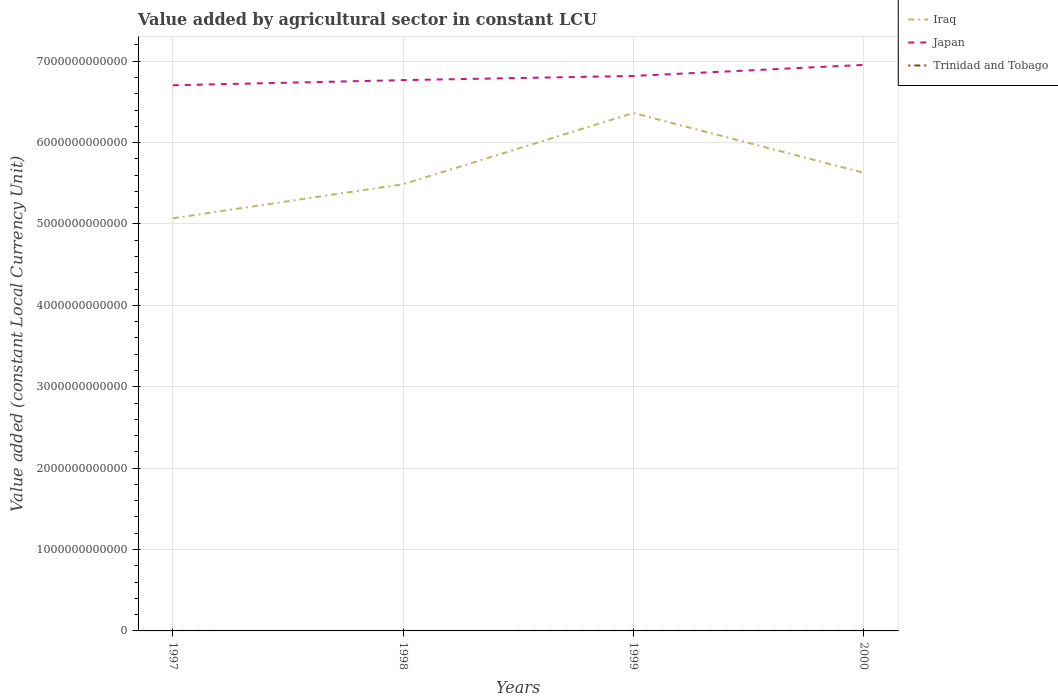Across all years, what is the maximum value added by agricultural sector in Japan?
Offer a very short reply. 6.70e+12. What is the total value added by agricultural sector in Iraq in the graph?
Keep it short and to the point. -1.40e+11. What is the difference between the highest and the second highest value added by agricultural sector in Japan?
Provide a succinct answer. 2.50e+11. How many lines are there?
Ensure brevity in your answer.  3. What is the difference between two consecutive major ticks on the Y-axis?
Keep it short and to the point. 1.00e+12. Does the graph contain any zero values?
Ensure brevity in your answer.  No. What is the title of the graph?
Keep it short and to the point. Value added by agricultural sector in constant LCU. Does "Angola" appear as one of the legend labels in the graph?
Provide a succinct answer. No. What is the label or title of the X-axis?
Your answer should be very brief. Years. What is the label or title of the Y-axis?
Make the answer very short. Value added (constant Local Currency Unit). What is the Value added (constant Local Currency Unit) of Iraq in 1997?
Provide a succinct answer. 5.07e+12. What is the Value added (constant Local Currency Unit) in Japan in 1997?
Offer a very short reply. 6.70e+12. What is the Value added (constant Local Currency Unit) in Trinidad and Tobago in 1997?
Offer a terse response. 6.75e+08. What is the Value added (constant Local Currency Unit) in Iraq in 1998?
Provide a short and direct response. 5.49e+12. What is the Value added (constant Local Currency Unit) of Japan in 1998?
Your answer should be very brief. 6.77e+12. What is the Value added (constant Local Currency Unit) of Trinidad and Tobago in 1998?
Give a very brief answer. 6.12e+08. What is the Value added (constant Local Currency Unit) of Iraq in 1999?
Ensure brevity in your answer.  6.36e+12. What is the Value added (constant Local Currency Unit) in Japan in 1999?
Offer a very short reply. 6.82e+12. What is the Value added (constant Local Currency Unit) in Trinidad and Tobago in 1999?
Give a very brief answer. 7.14e+08. What is the Value added (constant Local Currency Unit) in Iraq in 2000?
Make the answer very short. 5.63e+12. What is the Value added (constant Local Currency Unit) of Japan in 2000?
Give a very brief answer. 6.95e+12. What is the Value added (constant Local Currency Unit) in Trinidad and Tobago in 2000?
Give a very brief answer. 6.97e+08. Across all years, what is the maximum Value added (constant Local Currency Unit) in Iraq?
Make the answer very short. 6.36e+12. Across all years, what is the maximum Value added (constant Local Currency Unit) in Japan?
Your response must be concise. 6.95e+12. Across all years, what is the maximum Value added (constant Local Currency Unit) in Trinidad and Tobago?
Keep it short and to the point. 7.14e+08. Across all years, what is the minimum Value added (constant Local Currency Unit) in Iraq?
Your answer should be very brief. 5.07e+12. Across all years, what is the minimum Value added (constant Local Currency Unit) of Japan?
Provide a succinct answer. 6.70e+12. Across all years, what is the minimum Value added (constant Local Currency Unit) of Trinidad and Tobago?
Make the answer very short. 6.12e+08. What is the total Value added (constant Local Currency Unit) in Iraq in the graph?
Your answer should be very brief. 2.26e+13. What is the total Value added (constant Local Currency Unit) in Japan in the graph?
Keep it short and to the point. 2.72e+13. What is the total Value added (constant Local Currency Unit) in Trinidad and Tobago in the graph?
Offer a very short reply. 2.70e+09. What is the difference between the Value added (constant Local Currency Unit) in Iraq in 1997 and that in 1998?
Offer a terse response. -4.19e+11. What is the difference between the Value added (constant Local Currency Unit) of Japan in 1997 and that in 1998?
Offer a terse response. -6.31e+1. What is the difference between the Value added (constant Local Currency Unit) in Trinidad and Tobago in 1997 and that in 1998?
Your response must be concise. 6.28e+07. What is the difference between the Value added (constant Local Currency Unit) in Iraq in 1997 and that in 1999?
Your response must be concise. -1.29e+12. What is the difference between the Value added (constant Local Currency Unit) in Japan in 1997 and that in 1999?
Your answer should be compact. -1.15e+11. What is the difference between the Value added (constant Local Currency Unit) of Trinidad and Tobago in 1997 and that in 1999?
Provide a short and direct response. -3.92e+07. What is the difference between the Value added (constant Local Currency Unit) of Iraq in 1997 and that in 2000?
Offer a terse response. -5.58e+11. What is the difference between the Value added (constant Local Currency Unit) in Japan in 1997 and that in 2000?
Provide a succinct answer. -2.50e+11. What is the difference between the Value added (constant Local Currency Unit) of Trinidad and Tobago in 1997 and that in 2000?
Your answer should be compact. -2.23e+07. What is the difference between the Value added (constant Local Currency Unit) of Iraq in 1998 and that in 1999?
Provide a short and direct response. -8.75e+11. What is the difference between the Value added (constant Local Currency Unit) of Japan in 1998 and that in 1999?
Offer a terse response. -5.15e+1. What is the difference between the Value added (constant Local Currency Unit) of Trinidad and Tobago in 1998 and that in 1999?
Your answer should be compact. -1.02e+08. What is the difference between the Value added (constant Local Currency Unit) in Iraq in 1998 and that in 2000?
Your response must be concise. -1.40e+11. What is the difference between the Value added (constant Local Currency Unit) in Japan in 1998 and that in 2000?
Ensure brevity in your answer.  -1.87e+11. What is the difference between the Value added (constant Local Currency Unit) in Trinidad and Tobago in 1998 and that in 2000?
Your answer should be compact. -8.51e+07. What is the difference between the Value added (constant Local Currency Unit) of Iraq in 1999 and that in 2000?
Your answer should be very brief. 7.35e+11. What is the difference between the Value added (constant Local Currency Unit) of Japan in 1999 and that in 2000?
Provide a succinct answer. -1.36e+11. What is the difference between the Value added (constant Local Currency Unit) of Trinidad and Tobago in 1999 and that in 2000?
Offer a terse response. 1.69e+07. What is the difference between the Value added (constant Local Currency Unit) of Iraq in 1997 and the Value added (constant Local Currency Unit) of Japan in 1998?
Give a very brief answer. -1.70e+12. What is the difference between the Value added (constant Local Currency Unit) of Iraq in 1997 and the Value added (constant Local Currency Unit) of Trinidad and Tobago in 1998?
Ensure brevity in your answer.  5.07e+12. What is the difference between the Value added (constant Local Currency Unit) in Japan in 1997 and the Value added (constant Local Currency Unit) in Trinidad and Tobago in 1998?
Make the answer very short. 6.70e+12. What is the difference between the Value added (constant Local Currency Unit) in Iraq in 1997 and the Value added (constant Local Currency Unit) in Japan in 1999?
Your answer should be compact. -1.75e+12. What is the difference between the Value added (constant Local Currency Unit) of Iraq in 1997 and the Value added (constant Local Currency Unit) of Trinidad and Tobago in 1999?
Offer a terse response. 5.07e+12. What is the difference between the Value added (constant Local Currency Unit) in Japan in 1997 and the Value added (constant Local Currency Unit) in Trinidad and Tobago in 1999?
Your answer should be very brief. 6.70e+12. What is the difference between the Value added (constant Local Currency Unit) of Iraq in 1997 and the Value added (constant Local Currency Unit) of Japan in 2000?
Provide a succinct answer. -1.88e+12. What is the difference between the Value added (constant Local Currency Unit) of Iraq in 1997 and the Value added (constant Local Currency Unit) of Trinidad and Tobago in 2000?
Give a very brief answer. 5.07e+12. What is the difference between the Value added (constant Local Currency Unit) of Japan in 1997 and the Value added (constant Local Currency Unit) of Trinidad and Tobago in 2000?
Your answer should be compact. 6.70e+12. What is the difference between the Value added (constant Local Currency Unit) of Iraq in 1998 and the Value added (constant Local Currency Unit) of Japan in 1999?
Keep it short and to the point. -1.33e+12. What is the difference between the Value added (constant Local Currency Unit) of Iraq in 1998 and the Value added (constant Local Currency Unit) of Trinidad and Tobago in 1999?
Your answer should be compact. 5.49e+12. What is the difference between the Value added (constant Local Currency Unit) in Japan in 1998 and the Value added (constant Local Currency Unit) in Trinidad and Tobago in 1999?
Your answer should be very brief. 6.77e+12. What is the difference between the Value added (constant Local Currency Unit) of Iraq in 1998 and the Value added (constant Local Currency Unit) of Japan in 2000?
Your answer should be compact. -1.47e+12. What is the difference between the Value added (constant Local Currency Unit) of Iraq in 1998 and the Value added (constant Local Currency Unit) of Trinidad and Tobago in 2000?
Your response must be concise. 5.49e+12. What is the difference between the Value added (constant Local Currency Unit) of Japan in 1998 and the Value added (constant Local Currency Unit) of Trinidad and Tobago in 2000?
Make the answer very short. 6.77e+12. What is the difference between the Value added (constant Local Currency Unit) in Iraq in 1999 and the Value added (constant Local Currency Unit) in Japan in 2000?
Keep it short and to the point. -5.91e+11. What is the difference between the Value added (constant Local Currency Unit) of Iraq in 1999 and the Value added (constant Local Currency Unit) of Trinidad and Tobago in 2000?
Keep it short and to the point. 6.36e+12. What is the difference between the Value added (constant Local Currency Unit) of Japan in 1999 and the Value added (constant Local Currency Unit) of Trinidad and Tobago in 2000?
Provide a succinct answer. 6.82e+12. What is the average Value added (constant Local Currency Unit) of Iraq per year?
Offer a very short reply. 5.64e+12. What is the average Value added (constant Local Currency Unit) of Japan per year?
Offer a very short reply. 6.81e+12. What is the average Value added (constant Local Currency Unit) in Trinidad and Tobago per year?
Keep it short and to the point. 6.75e+08. In the year 1997, what is the difference between the Value added (constant Local Currency Unit) in Iraq and Value added (constant Local Currency Unit) in Japan?
Offer a terse response. -1.63e+12. In the year 1997, what is the difference between the Value added (constant Local Currency Unit) in Iraq and Value added (constant Local Currency Unit) in Trinidad and Tobago?
Your answer should be very brief. 5.07e+12. In the year 1997, what is the difference between the Value added (constant Local Currency Unit) in Japan and Value added (constant Local Currency Unit) in Trinidad and Tobago?
Provide a succinct answer. 6.70e+12. In the year 1998, what is the difference between the Value added (constant Local Currency Unit) of Iraq and Value added (constant Local Currency Unit) of Japan?
Your answer should be compact. -1.28e+12. In the year 1998, what is the difference between the Value added (constant Local Currency Unit) of Iraq and Value added (constant Local Currency Unit) of Trinidad and Tobago?
Your response must be concise. 5.49e+12. In the year 1998, what is the difference between the Value added (constant Local Currency Unit) of Japan and Value added (constant Local Currency Unit) of Trinidad and Tobago?
Provide a short and direct response. 6.77e+12. In the year 1999, what is the difference between the Value added (constant Local Currency Unit) in Iraq and Value added (constant Local Currency Unit) in Japan?
Provide a succinct answer. -4.55e+11. In the year 1999, what is the difference between the Value added (constant Local Currency Unit) of Iraq and Value added (constant Local Currency Unit) of Trinidad and Tobago?
Offer a terse response. 6.36e+12. In the year 1999, what is the difference between the Value added (constant Local Currency Unit) of Japan and Value added (constant Local Currency Unit) of Trinidad and Tobago?
Offer a very short reply. 6.82e+12. In the year 2000, what is the difference between the Value added (constant Local Currency Unit) in Iraq and Value added (constant Local Currency Unit) in Japan?
Your answer should be compact. -1.33e+12. In the year 2000, what is the difference between the Value added (constant Local Currency Unit) in Iraq and Value added (constant Local Currency Unit) in Trinidad and Tobago?
Your answer should be compact. 5.63e+12. In the year 2000, what is the difference between the Value added (constant Local Currency Unit) of Japan and Value added (constant Local Currency Unit) of Trinidad and Tobago?
Your answer should be very brief. 6.95e+12. What is the ratio of the Value added (constant Local Currency Unit) of Iraq in 1997 to that in 1998?
Offer a terse response. 0.92. What is the ratio of the Value added (constant Local Currency Unit) in Japan in 1997 to that in 1998?
Keep it short and to the point. 0.99. What is the ratio of the Value added (constant Local Currency Unit) in Trinidad and Tobago in 1997 to that in 1998?
Your answer should be compact. 1.1. What is the ratio of the Value added (constant Local Currency Unit) of Iraq in 1997 to that in 1999?
Give a very brief answer. 0.8. What is the ratio of the Value added (constant Local Currency Unit) in Japan in 1997 to that in 1999?
Provide a succinct answer. 0.98. What is the ratio of the Value added (constant Local Currency Unit) in Trinidad and Tobago in 1997 to that in 1999?
Provide a short and direct response. 0.95. What is the ratio of the Value added (constant Local Currency Unit) in Iraq in 1997 to that in 2000?
Provide a succinct answer. 0.9. What is the ratio of the Value added (constant Local Currency Unit) of Japan in 1997 to that in 2000?
Your answer should be very brief. 0.96. What is the ratio of the Value added (constant Local Currency Unit) in Trinidad and Tobago in 1997 to that in 2000?
Provide a short and direct response. 0.97. What is the ratio of the Value added (constant Local Currency Unit) in Iraq in 1998 to that in 1999?
Give a very brief answer. 0.86. What is the ratio of the Value added (constant Local Currency Unit) in Trinidad and Tobago in 1998 to that in 1999?
Your answer should be very brief. 0.86. What is the ratio of the Value added (constant Local Currency Unit) in Iraq in 1998 to that in 2000?
Your answer should be compact. 0.98. What is the ratio of the Value added (constant Local Currency Unit) of Japan in 1998 to that in 2000?
Ensure brevity in your answer.  0.97. What is the ratio of the Value added (constant Local Currency Unit) in Trinidad and Tobago in 1998 to that in 2000?
Your answer should be compact. 0.88. What is the ratio of the Value added (constant Local Currency Unit) in Iraq in 1999 to that in 2000?
Offer a terse response. 1.13. What is the ratio of the Value added (constant Local Currency Unit) in Japan in 1999 to that in 2000?
Make the answer very short. 0.98. What is the ratio of the Value added (constant Local Currency Unit) in Trinidad and Tobago in 1999 to that in 2000?
Your response must be concise. 1.02. What is the difference between the highest and the second highest Value added (constant Local Currency Unit) in Iraq?
Offer a very short reply. 7.35e+11. What is the difference between the highest and the second highest Value added (constant Local Currency Unit) in Japan?
Your answer should be very brief. 1.36e+11. What is the difference between the highest and the second highest Value added (constant Local Currency Unit) of Trinidad and Tobago?
Give a very brief answer. 1.69e+07. What is the difference between the highest and the lowest Value added (constant Local Currency Unit) in Iraq?
Your answer should be very brief. 1.29e+12. What is the difference between the highest and the lowest Value added (constant Local Currency Unit) of Japan?
Offer a terse response. 2.50e+11. What is the difference between the highest and the lowest Value added (constant Local Currency Unit) in Trinidad and Tobago?
Offer a terse response. 1.02e+08. 